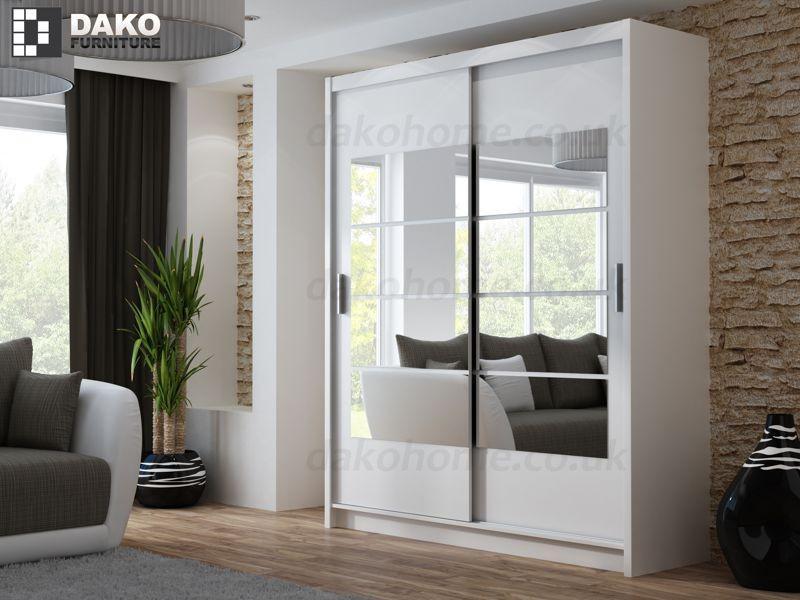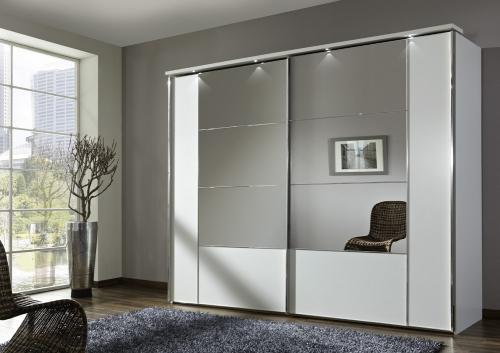The first image is the image on the left, the second image is the image on the right. For the images displayed, is the sentence "In each room there are mirrored sliding doors on the closet." factually correct? Answer yes or no. Yes. 